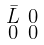<formula> <loc_0><loc_0><loc_500><loc_500>\begin{smallmatrix} \bar { L } & 0 \\ 0 & 0 \end{smallmatrix}</formula> 